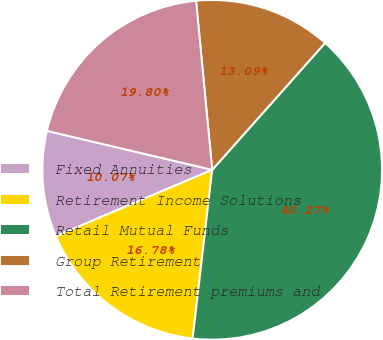<chart> <loc_0><loc_0><loc_500><loc_500><pie_chart><fcel>Fixed Annuities<fcel>Retirement Income Solutions<fcel>Retail Mutual Funds<fcel>Group Retirement<fcel>Total Retirement premiums and<nl><fcel>10.07%<fcel>16.78%<fcel>40.27%<fcel>13.09%<fcel>19.8%<nl></chart> 